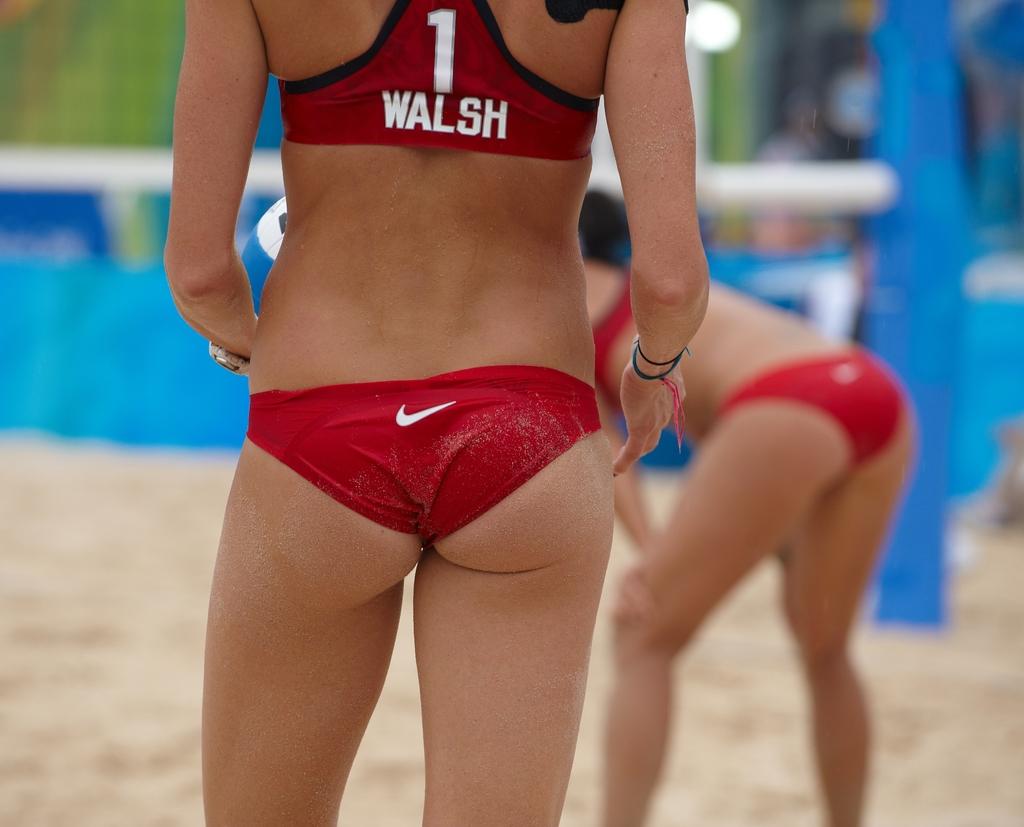What number is walsh?
Your answer should be compact. 1. Who wears number 1?
Ensure brevity in your answer.  Walsh. 